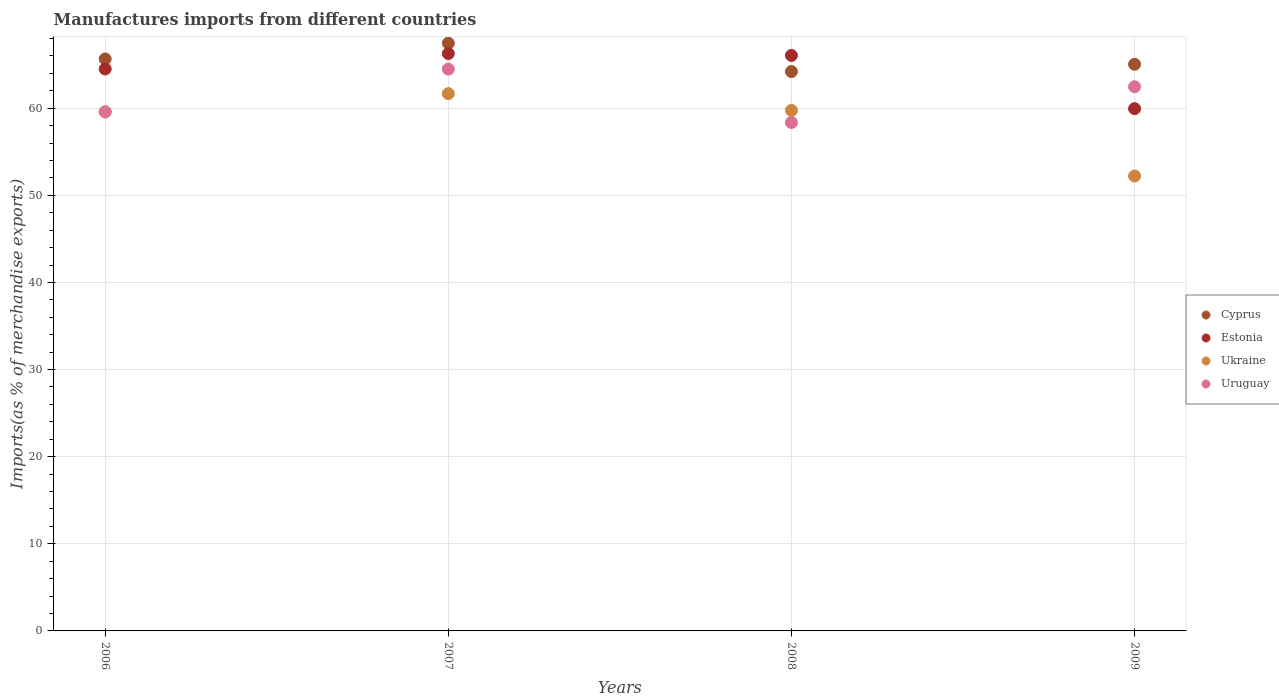How many different coloured dotlines are there?
Make the answer very short. 4. What is the percentage of imports to different countries in Estonia in 2009?
Offer a terse response. 59.95. Across all years, what is the maximum percentage of imports to different countries in Ukraine?
Make the answer very short. 61.68. Across all years, what is the minimum percentage of imports to different countries in Cyprus?
Ensure brevity in your answer.  64.21. In which year was the percentage of imports to different countries in Cyprus minimum?
Offer a terse response. 2008. What is the total percentage of imports to different countries in Cyprus in the graph?
Your response must be concise. 262.36. What is the difference between the percentage of imports to different countries in Estonia in 2007 and that in 2008?
Ensure brevity in your answer.  0.21. What is the difference between the percentage of imports to different countries in Cyprus in 2007 and the percentage of imports to different countries in Uruguay in 2008?
Your response must be concise. 9.1. What is the average percentage of imports to different countries in Estonia per year?
Make the answer very short. 64.2. In the year 2006, what is the difference between the percentage of imports to different countries in Cyprus and percentage of imports to different countries in Uruguay?
Offer a terse response. 6.07. In how many years, is the percentage of imports to different countries in Ukraine greater than 32 %?
Your response must be concise. 4. What is the ratio of the percentage of imports to different countries in Uruguay in 2008 to that in 2009?
Offer a very short reply. 0.93. What is the difference between the highest and the second highest percentage of imports to different countries in Cyprus?
Offer a very short reply. 1.81. What is the difference between the highest and the lowest percentage of imports to different countries in Uruguay?
Offer a terse response. 6.13. In how many years, is the percentage of imports to different countries in Estonia greater than the average percentage of imports to different countries in Estonia taken over all years?
Provide a succinct answer. 3. Is it the case that in every year, the sum of the percentage of imports to different countries in Uruguay and percentage of imports to different countries in Ukraine  is greater than the sum of percentage of imports to different countries in Estonia and percentage of imports to different countries in Cyprus?
Your answer should be very brief. No. Does the percentage of imports to different countries in Estonia monotonically increase over the years?
Offer a very short reply. No. How many years are there in the graph?
Offer a very short reply. 4. What is the difference between two consecutive major ticks on the Y-axis?
Keep it short and to the point. 10. Are the values on the major ticks of Y-axis written in scientific E-notation?
Keep it short and to the point. No. Does the graph contain any zero values?
Your answer should be compact. No. How are the legend labels stacked?
Provide a short and direct response. Vertical. What is the title of the graph?
Provide a succinct answer. Manufactures imports from different countries. What is the label or title of the X-axis?
Keep it short and to the point. Years. What is the label or title of the Y-axis?
Give a very brief answer. Imports(as % of merchandise exports). What is the Imports(as % of merchandise exports) in Cyprus in 2006?
Provide a short and direct response. 65.65. What is the Imports(as % of merchandise exports) in Estonia in 2006?
Your response must be concise. 64.5. What is the Imports(as % of merchandise exports) in Ukraine in 2006?
Ensure brevity in your answer.  59.58. What is the Imports(as % of merchandise exports) in Uruguay in 2006?
Your response must be concise. 59.58. What is the Imports(as % of merchandise exports) in Cyprus in 2007?
Provide a short and direct response. 67.46. What is the Imports(as % of merchandise exports) in Estonia in 2007?
Your answer should be compact. 66.27. What is the Imports(as % of merchandise exports) in Ukraine in 2007?
Make the answer very short. 61.68. What is the Imports(as % of merchandise exports) in Uruguay in 2007?
Give a very brief answer. 64.49. What is the Imports(as % of merchandise exports) of Cyprus in 2008?
Give a very brief answer. 64.21. What is the Imports(as % of merchandise exports) of Estonia in 2008?
Make the answer very short. 66.06. What is the Imports(as % of merchandise exports) in Ukraine in 2008?
Your response must be concise. 59.75. What is the Imports(as % of merchandise exports) in Uruguay in 2008?
Your answer should be compact. 58.36. What is the Imports(as % of merchandise exports) of Cyprus in 2009?
Provide a short and direct response. 65.04. What is the Imports(as % of merchandise exports) of Estonia in 2009?
Provide a short and direct response. 59.95. What is the Imports(as % of merchandise exports) in Ukraine in 2009?
Offer a terse response. 52.22. What is the Imports(as % of merchandise exports) of Uruguay in 2009?
Keep it short and to the point. 62.46. Across all years, what is the maximum Imports(as % of merchandise exports) of Cyprus?
Your response must be concise. 67.46. Across all years, what is the maximum Imports(as % of merchandise exports) in Estonia?
Offer a terse response. 66.27. Across all years, what is the maximum Imports(as % of merchandise exports) in Ukraine?
Your response must be concise. 61.68. Across all years, what is the maximum Imports(as % of merchandise exports) in Uruguay?
Provide a succinct answer. 64.49. Across all years, what is the minimum Imports(as % of merchandise exports) in Cyprus?
Offer a very short reply. 64.21. Across all years, what is the minimum Imports(as % of merchandise exports) of Estonia?
Provide a succinct answer. 59.95. Across all years, what is the minimum Imports(as % of merchandise exports) of Ukraine?
Your answer should be compact. 52.22. Across all years, what is the minimum Imports(as % of merchandise exports) in Uruguay?
Provide a succinct answer. 58.36. What is the total Imports(as % of merchandise exports) in Cyprus in the graph?
Your response must be concise. 262.36. What is the total Imports(as % of merchandise exports) in Estonia in the graph?
Provide a succinct answer. 256.79. What is the total Imports(as % of merchandise exports) of Ukraine in the graph?
Offer a terse response. 233.23. What is the total Imports(as % of merchandise exports) of Uruguay in the graph?
Make the answer very short. 244.89. What is the difference between the Imports(as % of merchandise exports) in Cyprus in 2006 and that in 2007?
Provide a succinct answer. -1.81. What is the difference between the Imports(as % of merchandise exports) of Estonia in 2006 and that in 2007?
Offer a very short reply. -1.77. What is the difference between the Imports(as % of merchandise exports) in Ukraine in 2006 and that in 2007?
Provide a short and direct response. -2.09. What is the difference between the Imports(as % of merchandise exports) in Uruguay in 2006 and that in 2007?
Your answer should be very brief. -4.91. What is the difference between the Imports(as % of merchandise exports) in Cyprus in 2006 and that in 2008?
Offer a terse response. 1.44. What is the difference between the Imports(as % of merchandise exports) in Estonia in 2006 and that in 2008?
Provide a short and direct response. -1.56. What is the difference between the Imports(as % of merchandise exports) in Ukraine in 2006 and that in 2008?
Make the answer very short. -0.17. What is the difference between the Imports(as % of merchandise exports) in Uruguay in 2006 and that in 2008?
Provide a succinct answer. 1.22. What is the difference between the Imports(as % of merchandise exports) of Cyprus in 2006 and that in 2009?
Your answer should be compact. 0.61. What is the difference between the Imports(as % of merchandise exports) in Estonia in 2006 and that in 2009?
Offer a very short reply. 4.56. What is the difference between the Imports(as % of merchandise exports) in Ukraine in 2006 and that in 2009?
Offer a very short reply. 7.36. What is the difference between the Imports(as % of merchandise exports) in Uruguay in 2006 and that in 2009?
Give a very brief answer. -2.88. What is the difference between the Imports(as % of merchandise exports) in Cyprus in 2007 and that in 2008?
Offer a very short reply. 3.25. What is the difference between the Imports(as % of merchandise exports) of Estonia in 2007 and that in 2008?
Your answer should be compact. 0.21. What is the difference between the Imports(as % of merchandise exports) in Ukraine in 2007 and that in 2008?
Keep it short and to the point. 1.93. What is the difference between the Imports(as % of merchandise exports) in Uruguay in 2007 and that in 2008?
Make the answer very short. 6.13. What is the difference between the Imports(as % of merchandise exports) in Cyprus in 2007 and that in 2009?
Offer a terse response. 2.42. What is the difference between the Imports(as % of merchandise exports) in Estonia in 2007 and that in 2009?
Offer a very short reply. 6.33. What is the difference between the Imports(as % of merchandise exports) in Ukraine in 2007 and that in 2009?
Make the answer very short. 9.46. What is the difference between the Imports(as % of merchandise exports) in Uruguay in 2007 and that in 2009?
Offer a terse response. 2.03. What is the difference between the Imports(as % of merchandise exports) of Cyprus in 2008 and that in 2009?
Offer a terse response. -0.84. What is the difference between the Imports(as % of merchandise exports) of Estonia in 2008 and that in 2009?
Give a very brief answer. 6.11. What is the difference between the Imports(as % of merchandise exports) of Ukraine in 2008 and that in 2009?
Offer a terse response. 7.53. What is the difference between the Imports(as % of merchandise exports) in Uruguay in 2008 and that in 2009?
Provide a short and direct response. -4.1. What is the difference between the Imports(as % of merchandise exports) of Cyprus in 2006 and the Imports(as % of merchandise exports) of Estonia in 2007?
Ensure brevity in your answer.  -0.62. What is the difference between the Imports(as % of merchandise exports) in Cyprus in 2006 and the Imports(as % of merchandise exports) in Ukraine in 2007?
Ensure brevity in your answer.  3.98. What is the difference between the Imports(as % of merchandise exports) of Cyprus in 2006 and the Imports(as % of merchandise exports) of Uruguay in 2007?
Make the answer very short. 1.16. What is the difference between the Imports(as % of merchandise exports) of Estonia in 2006 and the Imports(as % of merchandise exports) of Ukraine in 2007?
Keep it short and to the point. 2.83. What is the difference between the Imports(as % of merchandise exports) of Estonia in 2006 and the Imports(as % of merchandise exports) of Uruguay in 2007?
Your answer should be compact. 0.01. What is the difference between the Imports(as % of merchandise exports) of Ukraine in 2006 and the Imports(as % of merchandise exports) of Uruguay in 2007?
Your answer should be very brief. -4.91. What is the difference between the Imports(as % of merchandise exports) in Cyprus in 2006 and the Imports(as % of merchandise exports) in Estonia in 2008?
Offer a very short reply. -0.41. What is the difference between the Imports(as % of merchandise exports) of Cyprus in 2006 and the Imports(as % of merchandise exports) of Ukraine in 2008?
Ensure brevity in your answer.  5.9. What is the difference between the Imports(as % of merchandise exports) of Cyprus in 2006 and the Imports(as % of merchandise exports) of Uruguay in 2008?
Give a very brief answer. 7.29. What is the difference between the Imports(as % of merchandise exports) in Estonia in 2006 and the Imports(as % of merchandise exports) in Ukraine in 2008?
Your answer should be compact. 4.75. What is the difference between the Imports(as % of merchandise exports) of Estonia in 2006 and the Imports(as % of merchandise exports) of Uruguay in 2008?
Offer a very short reply. 6.15. What is the difference between the Imports(as % of merchandise exports) of Ukraine in 2006 and the Imports(as % of merchandise exports) of Uruguay in 2008?
Offer a very short reply. 1.22. What is the difference between the Imports(as % of merchandise exports) of Cyprus in 2006 and the Imports(as % of merchandise exports) of Estonia in 2009?
Keep it short and to the point. 5.7. What is the difference between the Imports(as % of merchandise exports) in Cyprus in 2006 and the Imports(as % of merchandise exports) in Ukraine in 2009?
Provide a short and direct response. 13.43. What is the difference between the Imports(as % of merchandise exports) in Cyprus in 2006 and the Imports(as % of merchandise exports) in Uruguay in 2009?
Provide a short and direct response. 3.19. What is the difference between the Imports(as % of merchandise exports) of Estonia in 2006 and the Imports(as % of merchandise exports) of Ukraine in 2009?
Your response must be concise. 12.29. What is the difference between the Imports(as % of merchandise exports) in Estonia in 2006 and the Imports(as % of merchandise exports) in Uruguay in 2009?
Offer a terse response. 2.04. What is the difference between the Imports(as % of merchandise exports) of Ukraine in 2006 and the Imports(as % of merchandise exports) of Uruguay in 2009?
Offer a terse response. -2.88. What is the difference between the Imports(as % of merchandise exports) in Cyprus in 2007 and the Imports(as % of merchandise exports) in Estonia in 2008?
Your response must be concise. 1.4. What is the difference between the Imports(as % of merchandise exports) in Cyprus in 2007 and the Imports(as % of merchandise exports) in Ukraine in 2008?
Offer a very short reply. 7.71. What is the difference between the Imports(as % of merchandise exports) in Cyprus in 2007 and the Imports(as % of merchandise exports) in Uruguay in 2008?
Provide a succinct answer. 9.1. What is the difference between the Imports(as % of merchandise exports) in Estonia in 2007 and the Imports(as % of merchandise exports) in Ukraine in 2008?
Ensure brevity in your answer.  6.52. What is the difference between the Imports(as % of merchandise exports) in Estonia in 2007 and the Imports(as % of merchandise exports) in Uruguay in 2008?
Keep it short and to the point. 7.92. What is the difference between the Imports(as % of merchandise exports) in Ukraine in 2007 and the Imports(as % of merchandise exports) in Uruguay in 2008?
Ensure brevity in your answer.  3.32. What is the difference between the Imports(as % of merchandise exports) in Cyprus in 2007 and the Imports(as % of merchandise exports) in Estonia in 2009?
Offer a terse response. 7.51. What is the difference between the Imports(as % of merchandise exports) of Cyprus in 2007 and the Imports(as % of merchandise exports) of Ukraine in 2009?
Give a very brief answer. 15.24. What is the difference between the Imports(as % of merchandise exports) of Cyprus in 2007 and the Imports(as % of merchandise exports) of Uruguay in 2009?
Offer a terse response. 5. What is the difference between the Imports(as % of merchandise exports) in Estonia in 2007 and the Imports(as % of merchandise exports) in Ukraine in 2009?
Give a very brief answer. 14.06. What is the difference between the Imports(as % of merchandise exports) in Estonia in 2007 and the Imports(as % of merchandise exports) in Uruguay in 2009?
Provide a succinct answer. 3.81. What is the difference between the Imports(as % of merchandise exports) in Ukraine in 2007 and the Imports(as % of merchandise exports) in Uruguay in 2009?
Offer a terse response. -0.79. What is the difference between the Imports(as % of merchandise exports) of Cyprus in 2008 and the Imports(as % of merchandise exports) of Estonia in 2009?
Your answer should be very brief. 4.26. What is the difference between the Imports(as % of merchandise exports) in Cyprus in 2008 and the Imports(as % of merchandise exports) in Ukraine in 2009?
Offer a terse response. 11.99. What is the difference between the Imports(as % of merchandise exports) in Cyprus in 2008 and the Imports(as % of merchandise exports) in Uruguay in 2009?
Your answer should be compact. 1.75. What is the difference between the Imports(as % of merchandise exports) of Estonia in 2008 and the Imports(as % of merchandise exports) of Ukraine in 2009?
Provide a short and direct response. 13.84. What is the difference between the Imports(as % of merchandise exports) in Estonia in 2008 and the Imports(as % of merchandise exports) in Uruguay in 2009?
Provide a short and direct response. 3.6. What is the difference between the Imports(as % of merchandise exports) of Ukraine in 2008 and the Imports(as % of merchandise exports) of Uruguay in 2009?
Offer a very short reply. -2.71. What is the average Imports(as % of merchandise exports) of Cyprus per year?
Your response must be concise. 65.59. What is the average Imports(as % of merchandise exports) in Estonia per year?
Give a very brief answer. 64.2. What is the average Imports(as % of merchandise exports) in Ukraine per year?
Provide a short and direct response. 58.31. What is the average Imports(as % of merchandise exports) of Uruguay per year?
Give a very brief answer. 61.22. In the year 2006, what is the difference between the Imports(as % of merchandise exports) of Cyprus and Imports(as % of merchandise exports) of Estonia?
Provide a short and direct response. 1.15. In the year 2006, what is the difference between the Imports(as % of merchandise exports) in Cyprus and Imports(as % of merchandise exports) in Ukraine?
Provide a short and direct response. 6.07. In the year 2006, what is the difference between the Imports(as % of merchandise exports) in Cyprus and Imports(as % of merchandise exports) in Uruguay?
Provide a short and direct response. 6.07. In the year 2006, what is the difference between the Imports(as % of merchandise exports) in Estonia and Imports(as % of merchandise exports) in Ukraine?
Ensure brevity in your answer.  4.92. In the year 2006, what is the difference between the Imports(as % of merchandise exports) of Estonia and Imports(as % of merchandise exports) of Uruguay?
Your answer should be very brief. 4.92. In the year 2006, what is the difference between the Imports(as % of merchandise exports) in Ukraine and Imports(as % of merchandise exports) in Uruguay?
Your answer should be very brief. -0. In the year 2007, what is the difference between the Imports(as % of merchandise exports) in Cyprus and Imports(as % of merchandise exports) in Estonia?
Ensure brevity in your answer.  1.19. In the year 2007, what is the difference between the Imports(as % of merchandise exports) of Cyprus and Imports(as % of merchandise exports) of Ukraine?
Your answer should be very brief. 5.78. In the year 2007, what is the difference between the Imports(as % of merchandise exports) of Cyprus and Imports(as % of merchandise exports) of Uruguay?
Keep it short and to the point. 2.97. In the year 2007, what is the difference between the Imports(as % of merchandise exports) in Estonia and Imports(as % of merchandise exports) in Ukraine?
Your answer should be very brief. 4.6. In the year 2007, what is the difference between the Imports(as % of merchandise exports) in Estonia and Imports(as % of merchandise exports) in Uruguay?
Keep it short and to the point. 1.78. In the year 2007, what is the difference between the Imports(as % of merchandise exports) of Ukraine and Imports(as % of merchandise exports) of Uruguay?
Provide a succinct answer. -2.81. In the year 2008, what is the difference between the Imports(as % of merchandise exports) of Cyprus and Imports(as % of merchandise exports) of Estonia?
Your answer should be compact. -1.85. In the year 2008, what is the difference between the Imports(as % of merchandise exports) in Cyprus and Imports(as % of merchandise exports) in Ukraine?
Keep it short and to the point. 4.46. In the year 2008, what is the difference between the Imports(as % of merchandise exports) of Cyprus and Imports(as % of merchandise exports) of Uruguay?
Offer a very short reply. 5.85. In the year 2008, what is the difference between the Imports(as % of merchandise exports) in Estonia and Imports(as % of merchandise exports) in Ukraine?
Provide a short and direct response. 6.31. In the year 2008, what is the difference between the Imports(as % of merchandise exports) of Estonia and Imports(as % of merchandise exports) of Uruguay?
Offer a terse response. 7.7. In the year 2008, what is the difference between the Imports(as % of merchandise exports) in Ukraine and Imports(as % of merchandise exports) in Uruguay?
Provide a succinct answer. 1.39. In the year 2009, what is the difference between the Imports(as % of merchandise exports) in Cyprus and Imports(as % of merchandise exports) in Estonia?
Offer a very short reply. 5.1. In the year 2009, what is the difference between the Imports(as % of merchandise exports) in Cyprus and Imports(as % of merchandise exports) in Ukraine?
Offer a very short reply. 12.83. In the year 2009, what is the difference between the Imports(as % of merchandise exports) in Cyprus and Imports(as % of merchandise exports) in Uruguay?
Your response must be concise. 2.58. In the year 2009, what is the difference between the Imports(as % of merchandise exports) of Estonia and Imports(as % of merchandise exports) of Ukraine?
Your answer should be compact. 7.73. In the year 2009, what is the difference between the Imports(as % of merchandise exports) in Estonia and Imports(as % of merchandise exports) in Uruguay?
Your response must be concise. -2.51. In the year 2009, what is the difference between the Imports(as % of merchandise exports) of Ukraine and Imports(as % of merchandise exports) of Uruguay?
Make the answer very short. -10.24. What is the ratio of the Imports(as % of merchandise exports) in Cyprus in 2006 to that in 2007?
Provide a succinct answer. 0.97. What is the ratio of the Imports(as % of merchandise exports) in Estonia in 2006 to that in 2007?
Your answer should be compact. 0.97. What is the ratio of the Imports(as % of merchandise exports) in Ukraine in 2006 to that in 2007?
Your answer should be compact. 0.97. What is the ratio of the Imports(as % of merchandise exports) in Uruguay in 2006 to that in 2007?
Keep it short and to the point. 0.92. What is the ratio of the Imports(as % of merchandise exports) in Cyprus in 2006 to that in 2008?
Your response must be concise. 1.02. What is the ratio of the Imports(as % of merchandise exports) in Estonia in 2006 to that in 2008?
Give a very brief answer. 0.98. What is the ratio of the Imports(as % of merchandise exports) in Ukraine in 2006 to that in 2008?
Give a very brief answer. 1. What is the ratio of the Imports(as % of merchandise exports) of Uruguay in 2006 to that in 2008?
Offer a very short reply. 1.02. What is the ratio of the Imports(as % of merchandise exports) of Cyprus in 2006 to that in 2009?
Keep it short and to the point. 1.01. What is the ratio of the Imports(as % of merchandise exports) of Estonia in 2006 to that in 2009?
Keep it short and to the point. 1.08. What is the ratio of the Imports(as % of merchandise exports) in Ukraine in 2006 to that in 2009?
Keep it short and to the point. 1.14. What is the ratio of the Imports(as % of merchandise exports) in Uruguay in 2006 to that in 2009?
Ensure brevity in your answer.  0.95. What is the ratio of the Imports(as % of merchandise exports) in Cyprus in 2007 to that in 2008?
Keep it short and to the point. 1.05. What is the ratio of the Imports(as % of merchandise exports) of Ukraine in 2007 to that in 2008?
Your response must be concise. 1.03. What is the ratio of the Imports(as % of merchandise exports) in Uruguay in 2007 to that in 2008?
Keep it short and to the point. 1.11. What is the ratio of the Imports(as % of merchandise exports) in Cyprus in 2007 to that in 2009?
Ensure brevity in your answer.  1.04. What is the ratio of the Imports(as % of merchandise exports) of Estonia in 2007 to that in 2009?
Your answer should be compact. 1.11. What is the ratio of the Imports(as % of merchandise exports) of Ukraine in 2007 to that in 2009?
Offer a terse response. 1.18. What is the ratio of the Imports(as % of merchandise exports) of Uruguay in 2007 to that in 2009?
Your response must be concise. 1.03. What is the ratio of the Imports(as % of merchandise exports) of Cyprus in 2008 to that in 2009?
Offer a very short reply. 0.99. What is the ratio of the Imports(as % of merchandise exports) in Estonia in 2008 to that in 2009?
Your response must be concise. 1.1. What is the ratio of the Imports(as % of merchandise exports) in Ukraine in 2008 to that in 2009?
Provide a succinct answer. 1.14. What is the ratio of the Imports(as % of merchandise exports) of Uruguay in 2008 to that in 2009?
Provide a succinct answer. 0.93. What is the difference between the highest and the second highest Imports(as % of merchandise exports) of Cyprus?
Provide a short and direct response. 1.81. What is the difference between the highest and the second highest Imports(as % of merchandise exports) in Estonia?
Your answer should be very brief. 0.21. What is the difference between the highest and the second highest Imports(as % of merchandise exports) of Ukraine?
Give a very brief answer. 1.93. What is the difference between the highest and the second highest Imports(as % of merchandise exports) of Uruguay?
Provide a succinct answer. 2.03. What is the difference between the highest and the lowest Imports(as % of merchandise exports) in Cyprus?
Your response must be concise. 3.25. What is the difference between the highest and the lowest Imports(as % of merchandise exports) in Estonia?
Give a very brief answer. 6.33. What is the difference between the highest and the lowest Imports(as % of merchandise exports) in Ukraine?
Keep it short and to the point. 9.46. What is the difference between the highest and the lowest Imports(as % of merchandise exports) in Uruguay?
Ensure brevity in your answer.  6.13. 